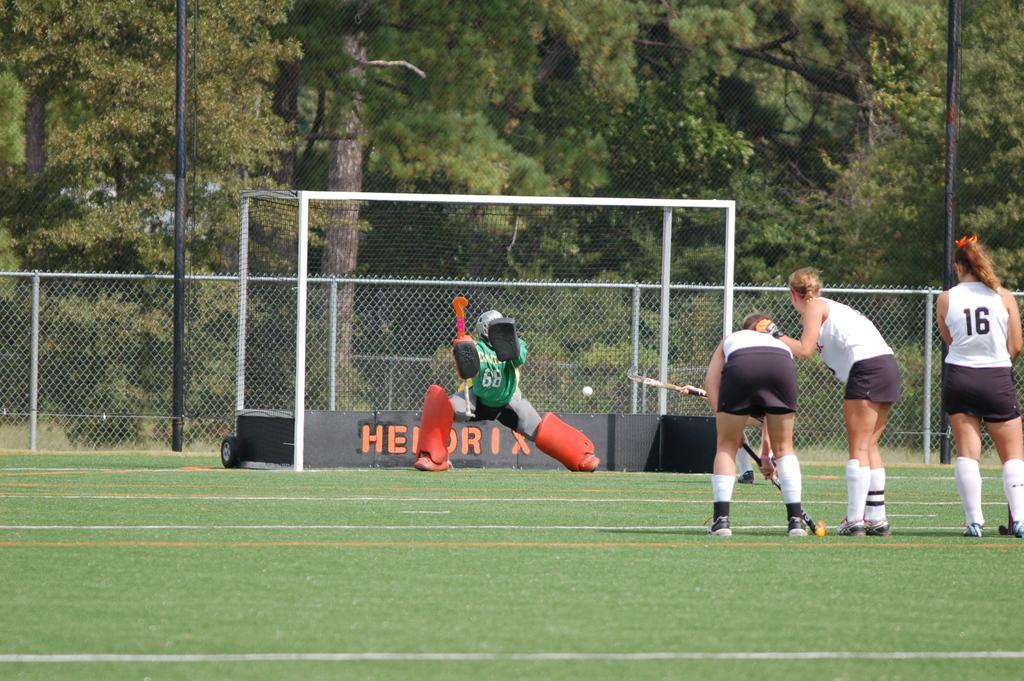<image>
Write a terse but informative summary of the picture. A soccer player on the right has the number 16 on their back 